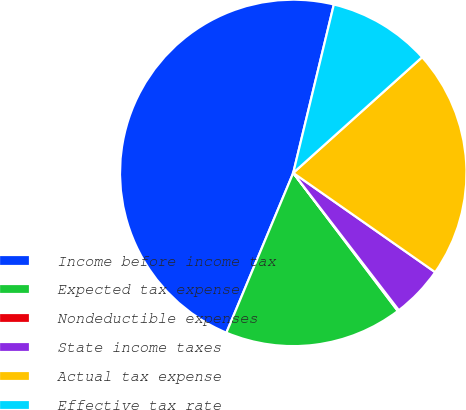Convert chart. <chart><loc_0><loc_0><loc_500><loc_500><pie_chart><fcel>Income before income tax<fcel>Expected tax expense<fcel>Nondeductible expenses<fcel>State income taxes<fcel>Actual tax expense<fcel>Effective tax rate<nl><fcel>47.46%<fcel>16.62%<fcel>0.12%<fcel>4.85%<fcel>21.36%<fcel>9.59%<nl></chart> 